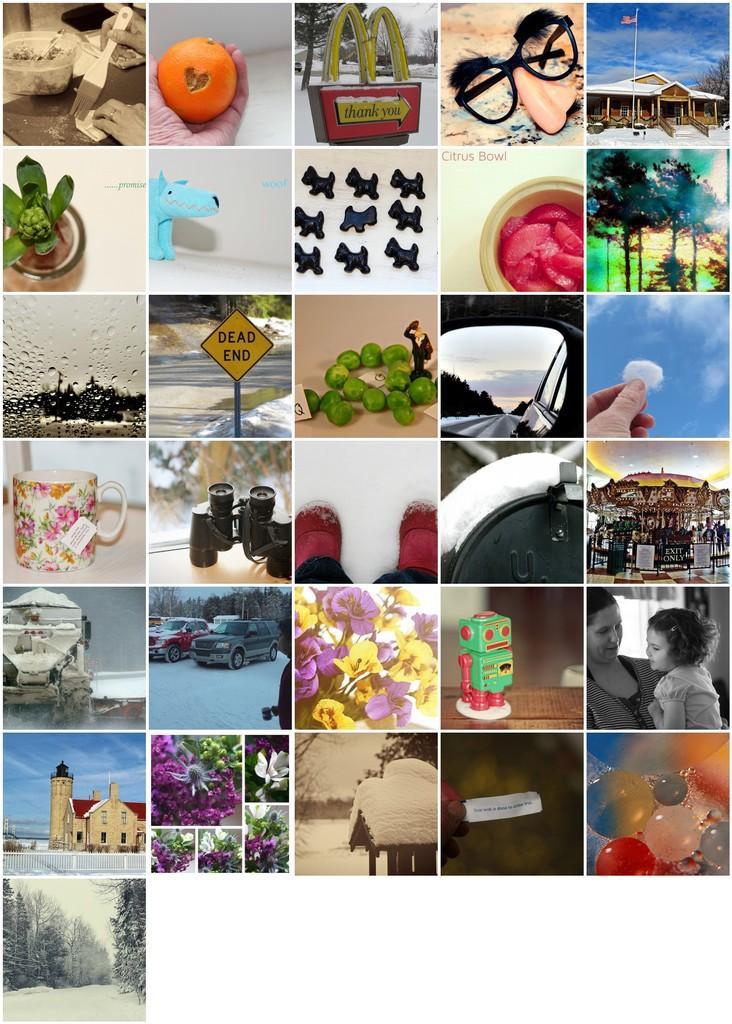In one or two sentences, can you explain what this image depicts? In this image we can see a collage of so many images. 